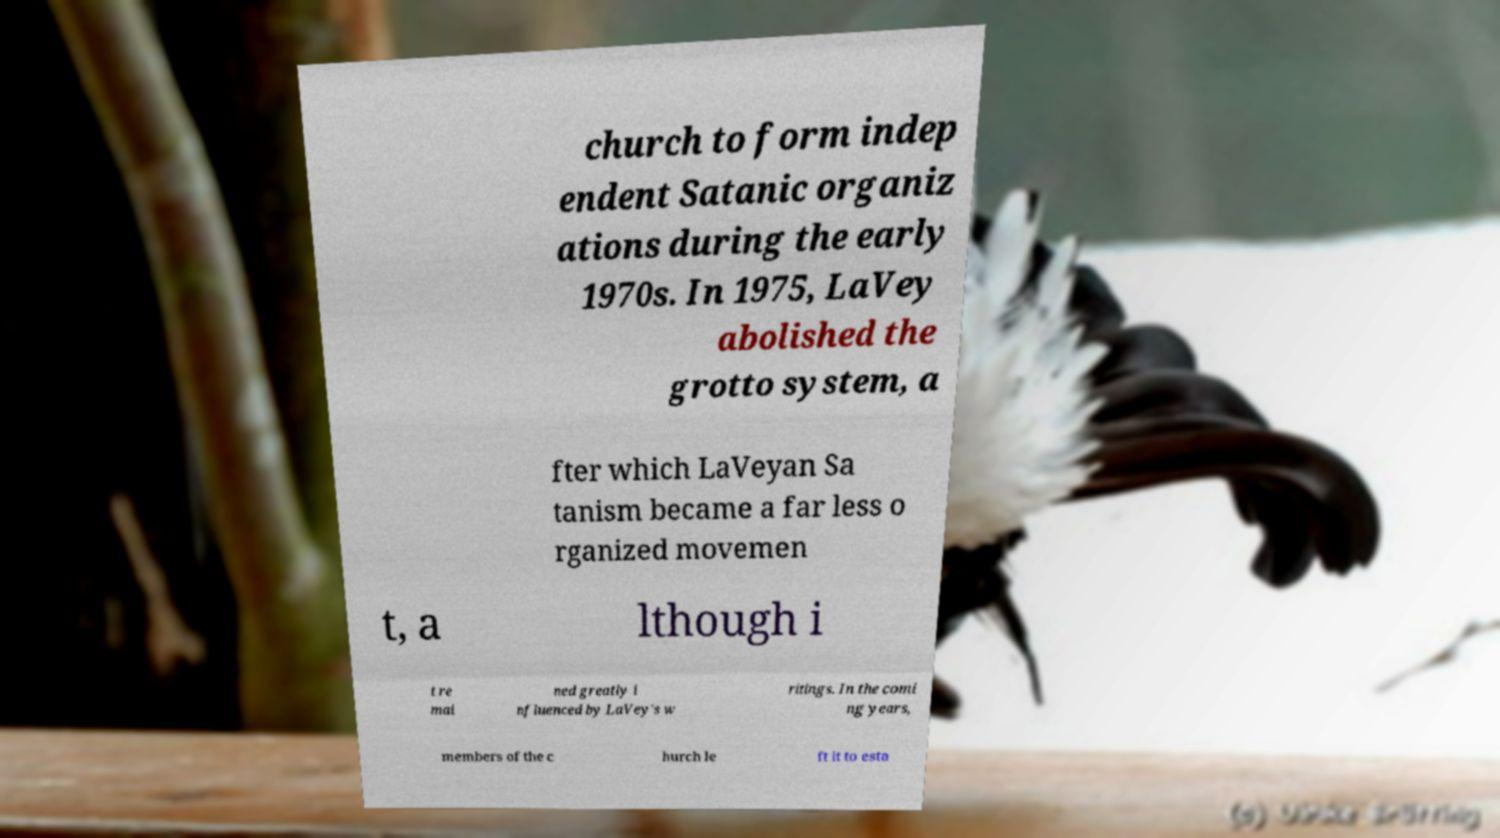Could you assist in decoding the text presented in this image and type it out clearly? church to form indep endent Satanic organiz ations during the early 1970s. In 1975, LaVey abolished the grotto system, a fter which LaVeyan Sa tanism became a far less o rganized movemen t, a lthough i t re mai ned greatly i nfluenced by LaVey's w ritings. In the comi ng years, members of the c hurch le ft it to esta 